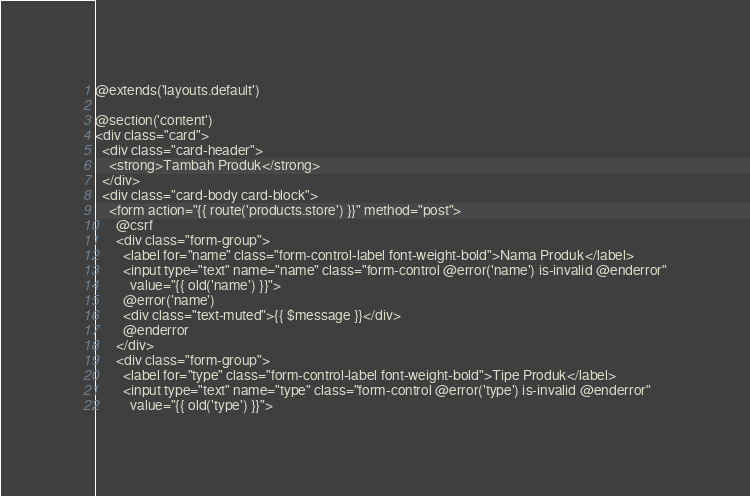Convert code to text. <code><loc_0><loc_0><loc_500><loc_500><_PHP_>@extends('layouts.default')

@section('content')
<div class="card">
  <div class="card-header">
    <strong>Tambah Produk</strong>
  </div>
  <div class="card-body card-block">
    <form action="{{ route('products.store') }}" method="post">
      @csrf
      <div class="form-group">
        <label for="name" class="form-control-label font-weight-bold">Nama Produk</label>
        <input type="text" name="name" class="form-control @error('name') is-invalid @enderror"
          value="{{ old('name') }}">
        @error('name')
        <div class="text-muted">{{ $message }}</div>
        @enderror
      </div>
      <div class="form-group">
        <label for="type" class="form-control-label font-weight-bold">Tipe Produk</label>
        <input type="text" name="type" class="form-control @error('type') is-invalid @enderror"
          value="{{ old('type') }}"></code> 